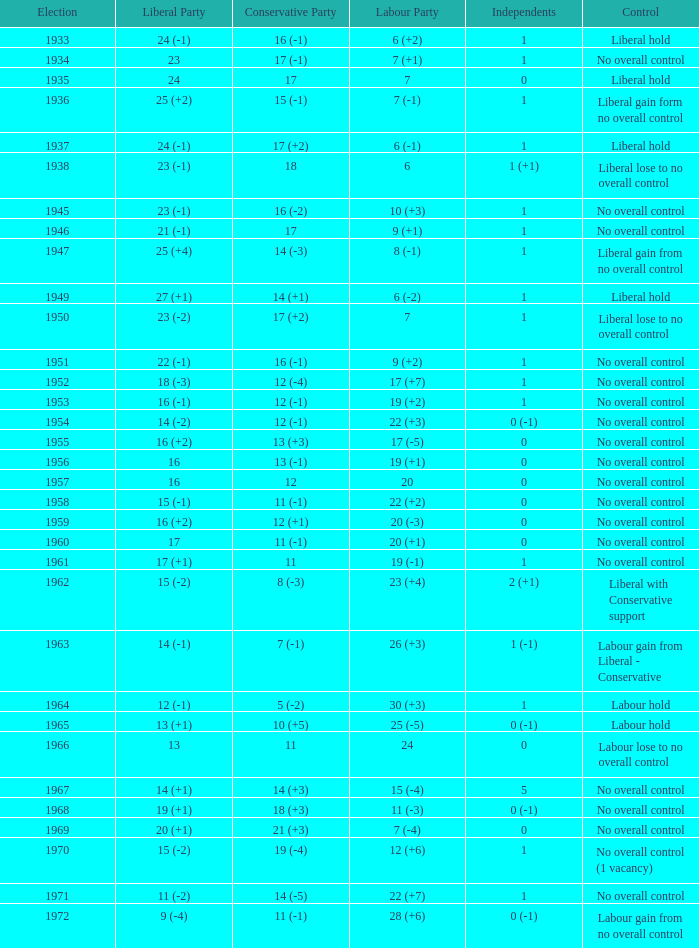Who was in control the year that Labour Party won 12 (+6) seats? No overall control (1 vacancy). 